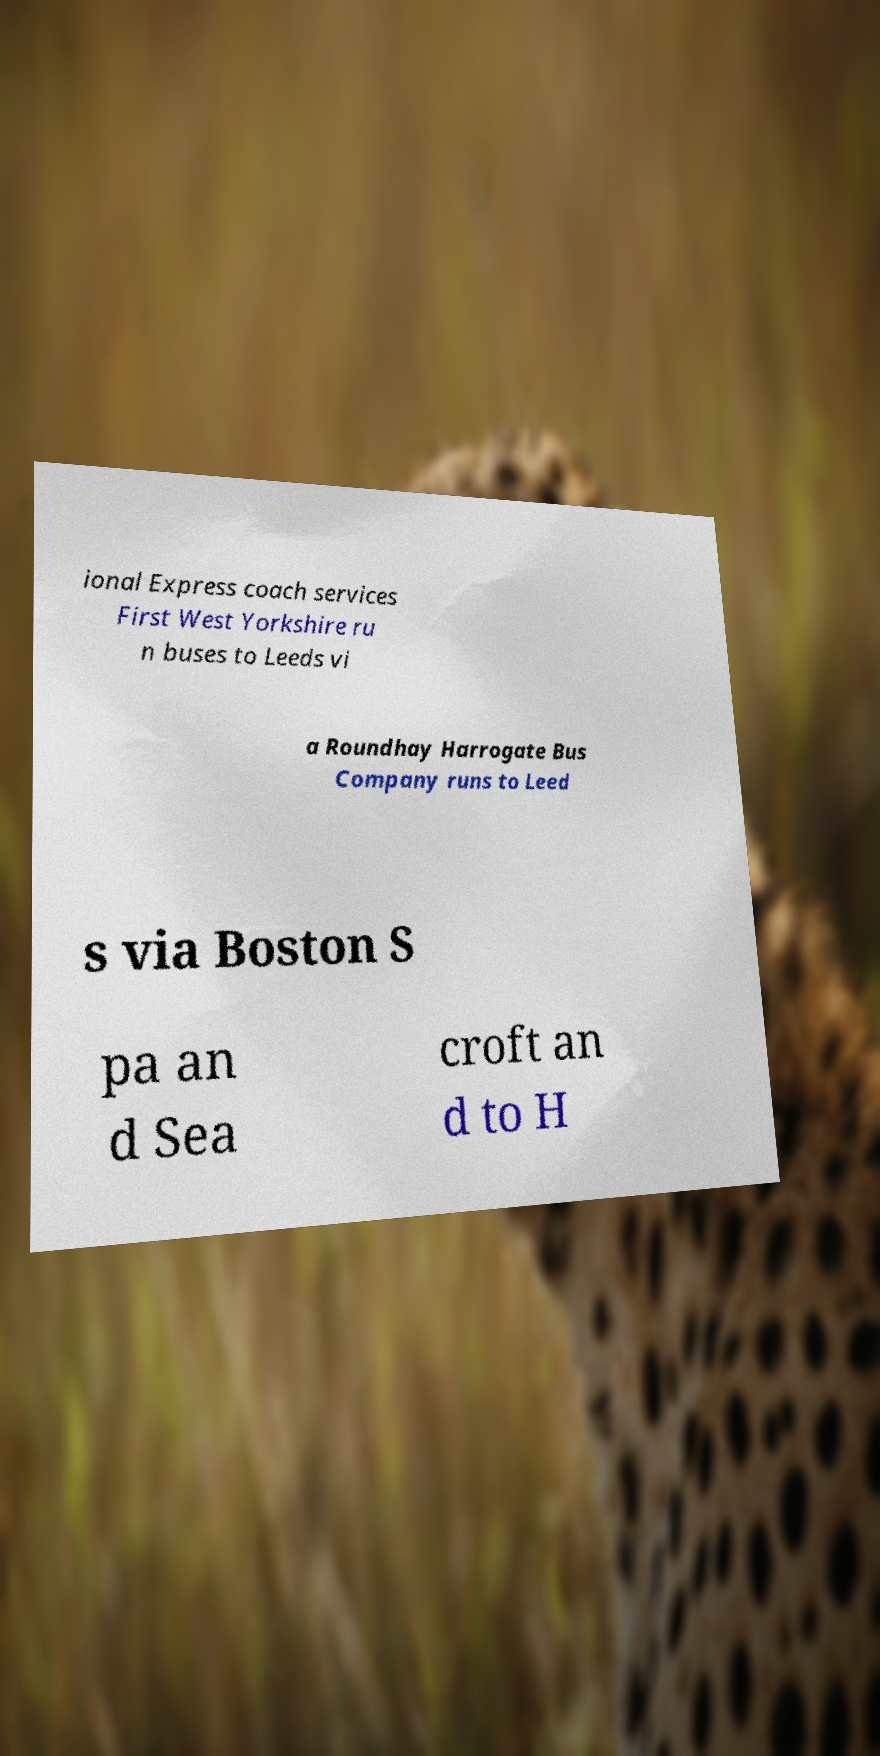Please identify and transcribe the text found in this image. ional Express coach services First West Yorkshire ru n buses to Leeds vi a Roundhay Harrogate Bus Company runs to Leed s via Boston S pa an d Sea croft an d to H 